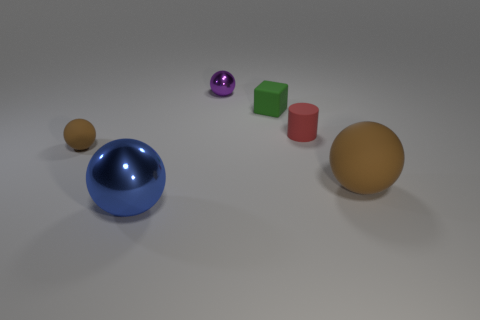Why is there a difference in the finish of the objects? The differing finishes—matte for the cubes and glossy for the spheres—demonstrate contrast and variety in texture. Such visual diversity can make an image more appealing and can serve educational purposes for understanding how different materials interact with light. 